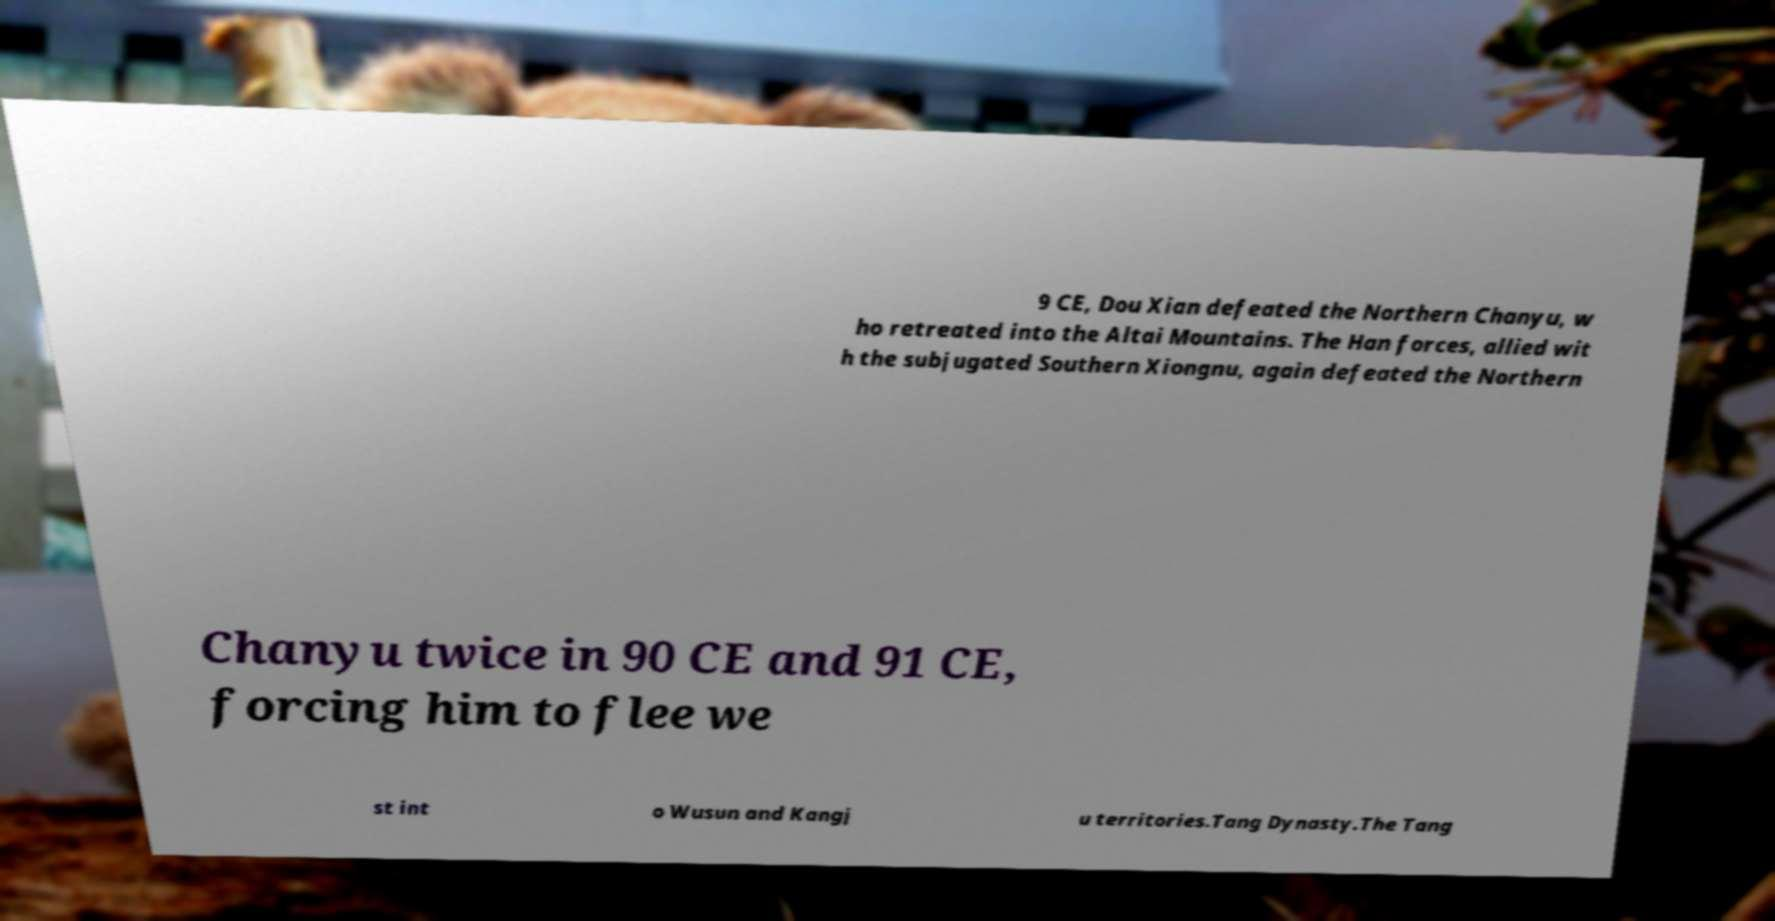Could you assist in decoding the text presented in this image and type it out clearly? 9 CE, Dou Xian defeated the Northern Chanyu, w ho retreated into the Altai Mountains. The Han forces, allied wit h the subjugated Southern Xiongnu, again defeated the Northern Chanyu twice in 90 CE and 91 CE, forcing him to flee we st int o Wusun and Kangj u territories.Tang Dynasty.The Tang 